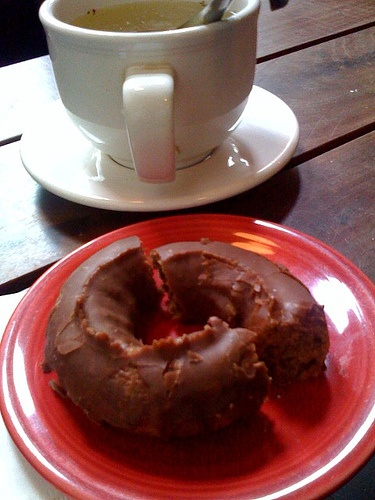Describe the objects in this image and their specific colors. I can see donut in black, maroon, and brown tones and cup in black, gray, darkgray, and brown tones in this image. 